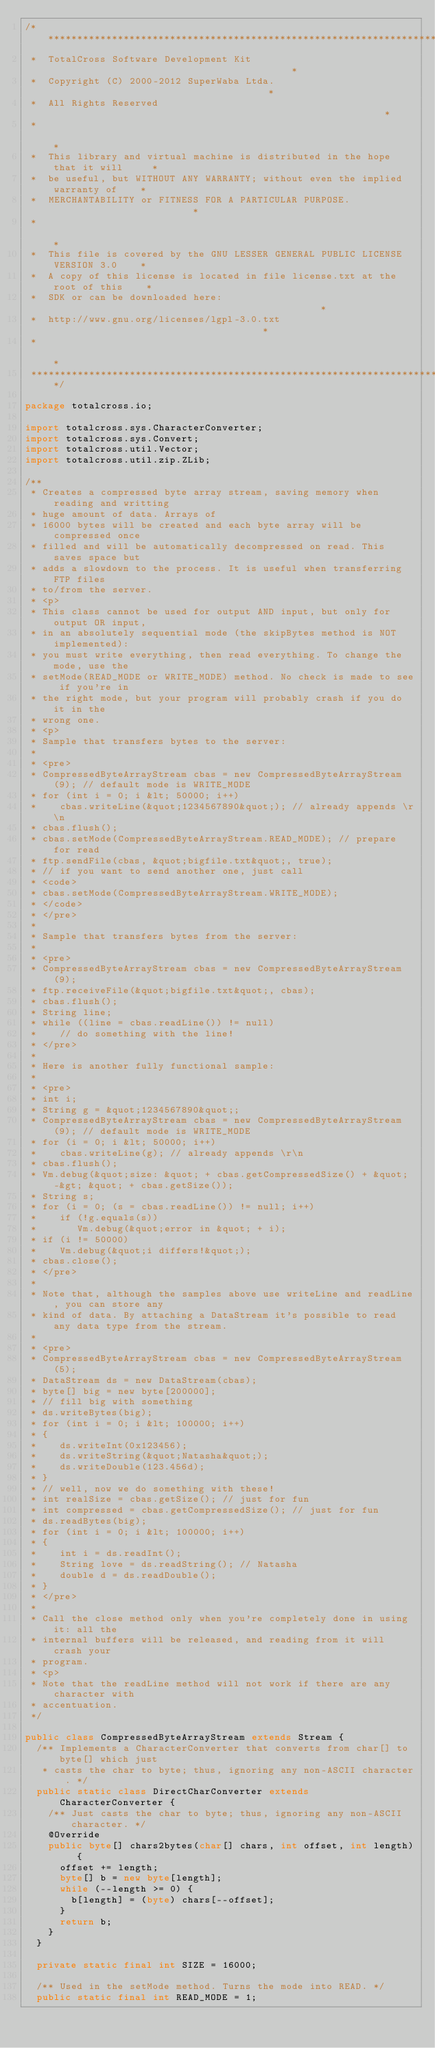Convert code to text. <code><loc_0><loc_0><loc_500><loc_500><_Java_>/*********************************************************************************
 *  TotalCross Software Development Kit                                          *
 *  Copyright (C) 2000-2012 SuperWaba Ltda.                                      *
 *  All Rights Reserved                                                          *
 *                                                                               *
 *  This library and virtual machine is distributed in the hope that it will     *
 *  be useful, but WITHOUT ANY WARRANTY; without even the implied warranty of    *
 *  MERCHANTABILITY or FITNESS FOR A PARTICULAR PURPOSE.                         *
 *                                                                               *
 *  This file is covered by the GNU LESSER GENERAL PUBLIC LICENSE VERSION 3.0    *
 *  A copy of this license is located in file license.txt at the root of this    *
 *  SDK or can be downloaded here:                                               *
 *  http://www.gnu.org/licenses/lgpl-3.0.txt                                     *
 *                                                                               *
 *********************************************************************************/

package totalcross.io;

import totalcross.sys.CharacterConverter;
import totalcross.sys.Convert;
import totalcross.util.Vector;
import totalcross.util.zip.ZLib;

/**
 * Creates a compressed byte array stream, saving memory when reading and writting
 * huge amount of data. Arrays of
 * 16000 bytes will be created and each byte array will be compressed once
 * filled and will be automatically decompressed on read. This saves space but
 * adds a slowdown to the process. It is useful when transferring FTP files
 * to/from the server.
 * <p>
 * This class cannot be used for output AND input, but only for output OR input,
 * in an absolutely sequential mode (the skipBytes method is NOT implemented):
 * you must write everything, then read everything. To change the mode, use the
 * setMode(READ_MODE or WRITE_MODE) method. No check is made to see if you're in
 * the right mode, but your program will probably crash if you do it in the
 * wrong one.
 * <p>
 * Sample that transfers bytes to the server:
 *
 * <pre>
 * CompressedByteArrayStream cbas = new CompressedByteArrayStream(9); // default mode is WRITE_MODE
 * for (int i = 0; i &lt; 50000; i++)
 *    cbas.writeLine(&quot;1234567890&quot;); // already appends \r\n
 * cbas.flush();
 * cbas.setMode(CompressedByteArrayStream.READ_MODE); // prepare for read
 * ftp.sendFile(cbas, &quot;bigfile.txt&quot;, true);
 * // if you want to send another one, just call
 * <code>
 * cbas.setMode(CompressedByteArrayStream.WRITE_MODE);
 * </code>
 * </pre>
 *
 * Sample that transfers bytes from the server:
 *
 * <pre>
 * CompressedByteArrayStream cbas = new CompressedByteArrayStream(9);
 * ftp.receiveFile(&quot;bigfile.txt&quot;, cbas);
 * cbas.flush();
 * String line;
 * while ((line = cbas.readLine()) != null)
 *    // do something with the line!
 * </pre>
 *
 * Here is another fully functional sample:
 *
 * <pre>
 * int i;
 * String g = &quot;1234567890&quot;;
 * CompressedByteArrayStream cbas = new CompressedByteArrayStream(9); // default mode is WRITE_MODE
 * for (i = 0; i &lt; 50000; i++)
 *    cbas.writeLine(g); // already appends \r\n
 * cbas.flush();
 * Vm.debug(&quot;size: &quot; + cbas.getCompressedSize() + &quot; -&gt; &quot; + cbas.getSize());
 * String s;
 * for (i = 0; (s = cbas.readLine()) != null; i++)
 *    if (!g.equals(s))
 *       Vm.debug(&quot;error in &quot; + i);
 * if (i != 50000)
 *    Vm.debug(&quot;i differs!&quot;);
 * cbas.close();
 * </pre>
 *
 * Note that, although the samples above use writeLine and readLine, you can store any
 * kind of data. By attaching a DataStream it's possible to read any data type from the stream.
 *
 * <pre>
 * CompressedByteArrayStream cbas = new CompressedByteArrayStream(5);
 * DataStream ds = new DataStream(cbas);
 * byte[] big = new byte[200000];
 * // fill big with something
 * ds.writeBytes(big);
 * for (int i = 0; i &lt; 100000; i++)
 * {
 *    ds.writeInt(0x123456);
 *    ds.writeString(&quot;Natasha&quot;);
 *    ds.writeDouble(123.456d);
 * }
 * // well, now we do something with these!
 * int realSize = cbas.getSize(); // just for fun
 * int compressed = cbas.getCompressedSize(); // just for fun
 * ds.readBytes(big);
 * for (int i = 0; i &lt; 100000; i++)
 * {
 *    int i = ds.readInt();
 *    String love = ds.readString(); // Natasha
 *    double d = ds.readDouble();
 * }
 * </pre>
 *
 * Call the close method only when you're completely done in using it: all the
 * internal buffers will be released, and reading from it will crash your
 * program.
 * <p>
 * Note that the readLine method will not work if there are any character with
 * accentuation.
 */

public class CompressedByteArrayStream extends Stream {
  /** Implements a CharacterConverter that converts from char[] to byte[] which just
   * casts the char to byte; thus, ignoring any non-ASCII character. */
  public static class DirectCharConverter extends CharacterConverter {
    /** Just casts the char to byte; thus, ignoring any non-ASCII character. */
    @Override
    public byte[] chars2bytes(char[] chars, int offset, int length) {
      offset += length;
      byte[] b = new byte[length];
      while (--length >= 0) {
        b[length] = (byte) chars[--offset];
      }
      return b;
    }
  }

  private static final int SIZE = 16000;

  /** Used in the setMode method. Turns the mode into READ. */
  public static final int READ_MODE = 1;</code> 